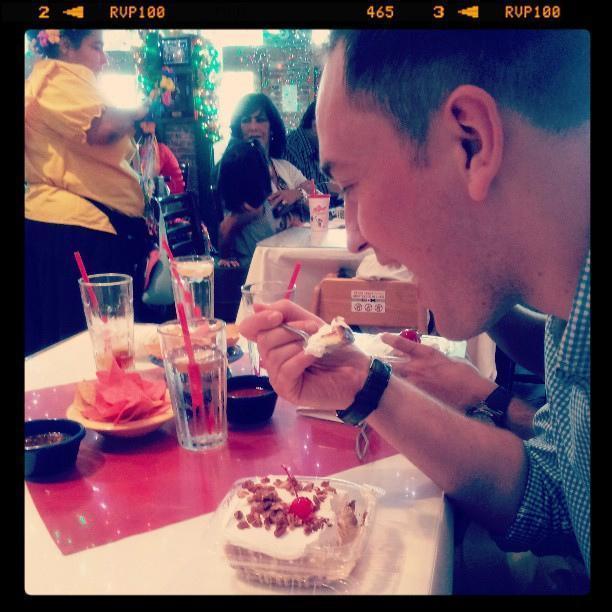How many chairs can be seen?
Give a very brief answer. 2. How many people are in the photo?
Give a very brief answer. 5. How many cups can be seen?
Give a very brief answer. 3. How many dining tables are visible?
Give a very brief answer. 2. How many bowls are there?
Give a very brief answer. 2. How many surfboards are there?
Give a very brief answer. 0. 